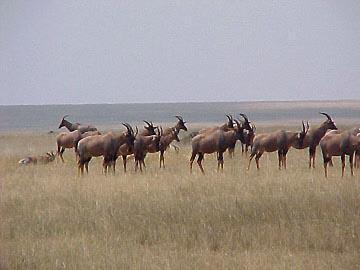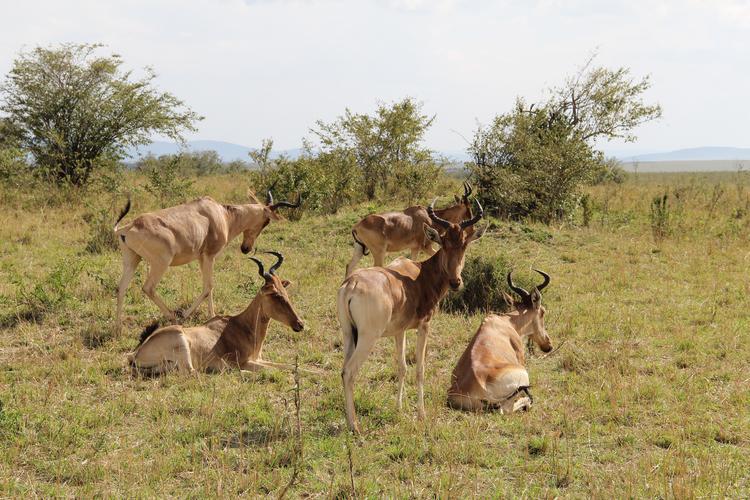The first image is the image on the left, the second image is the image on the right. Assess this claim about the two images: "The antelope in the left image furthest to the left is facing towards the left.". Correct or not? Answer yes or no. No. 